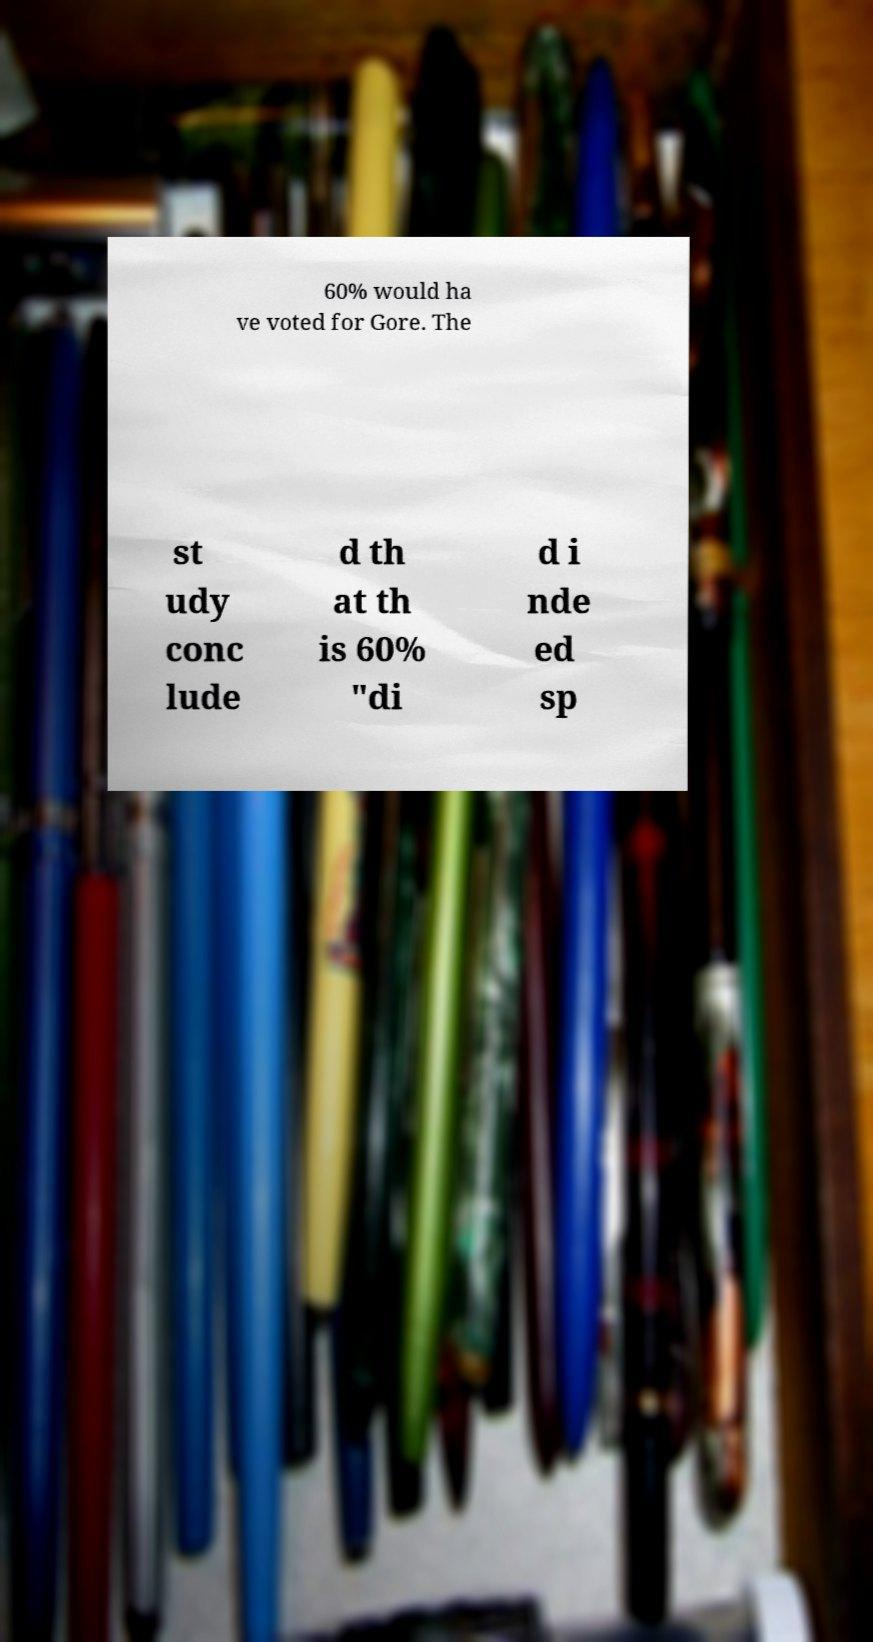Please read and relay the text visible in this image. What does it say? 60% would ha ve voted for Gore. The st udy conc lude d th at th is 60% "di d i nde ed sp 